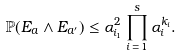Convert formula to latex. <formula><loc_0><loc_0><loc_500><loc_500>\mathbb { P } ( E _ { a } \wedge E _ { a ^ { \prime } } ) \leq \alpha _ { i _ { 1 } } ^ { 2 } \prod _ { i \, = \, 1 } ^ { s } \alpha _ { i } ^ { k _ { i } } .</formula> 